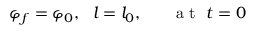<formula> <loc_0><loc_0><loc_500><loc_500>\varphi _ { f } = \varphi _ { 0 } , l = l _ { 0 } , a t t = 0</formula> 